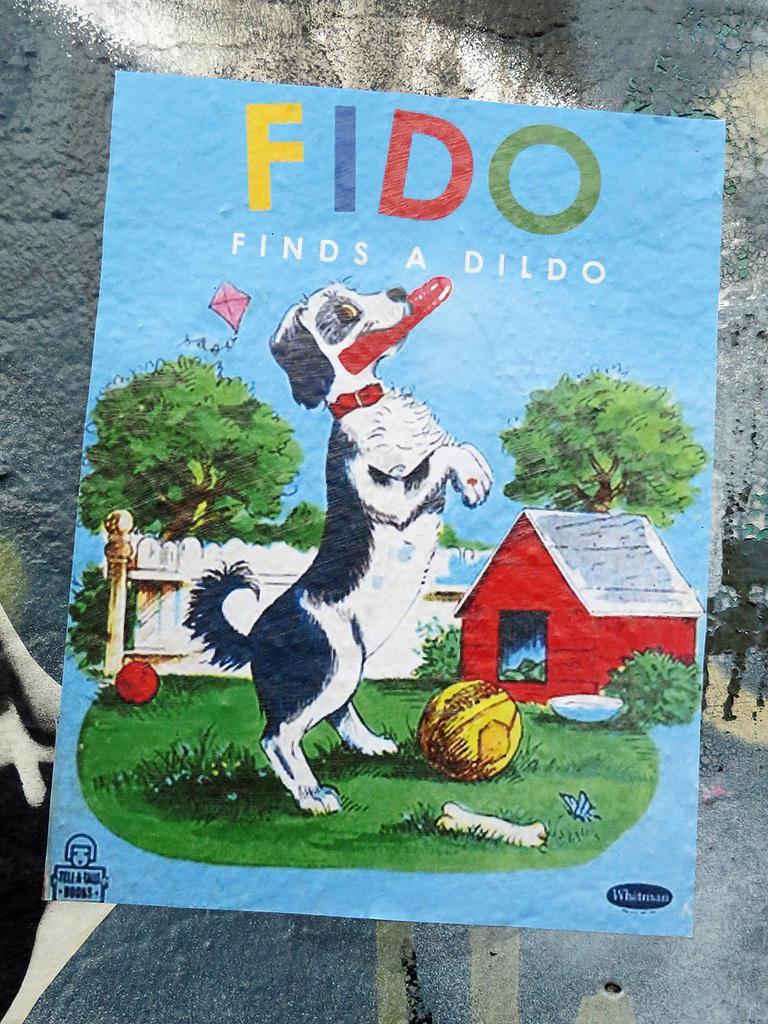Describe this image in one or two sentences. In this image we can see a painting of a dog and two balls on the ground. In the background, we can see a building, group of trees and some text on it. 